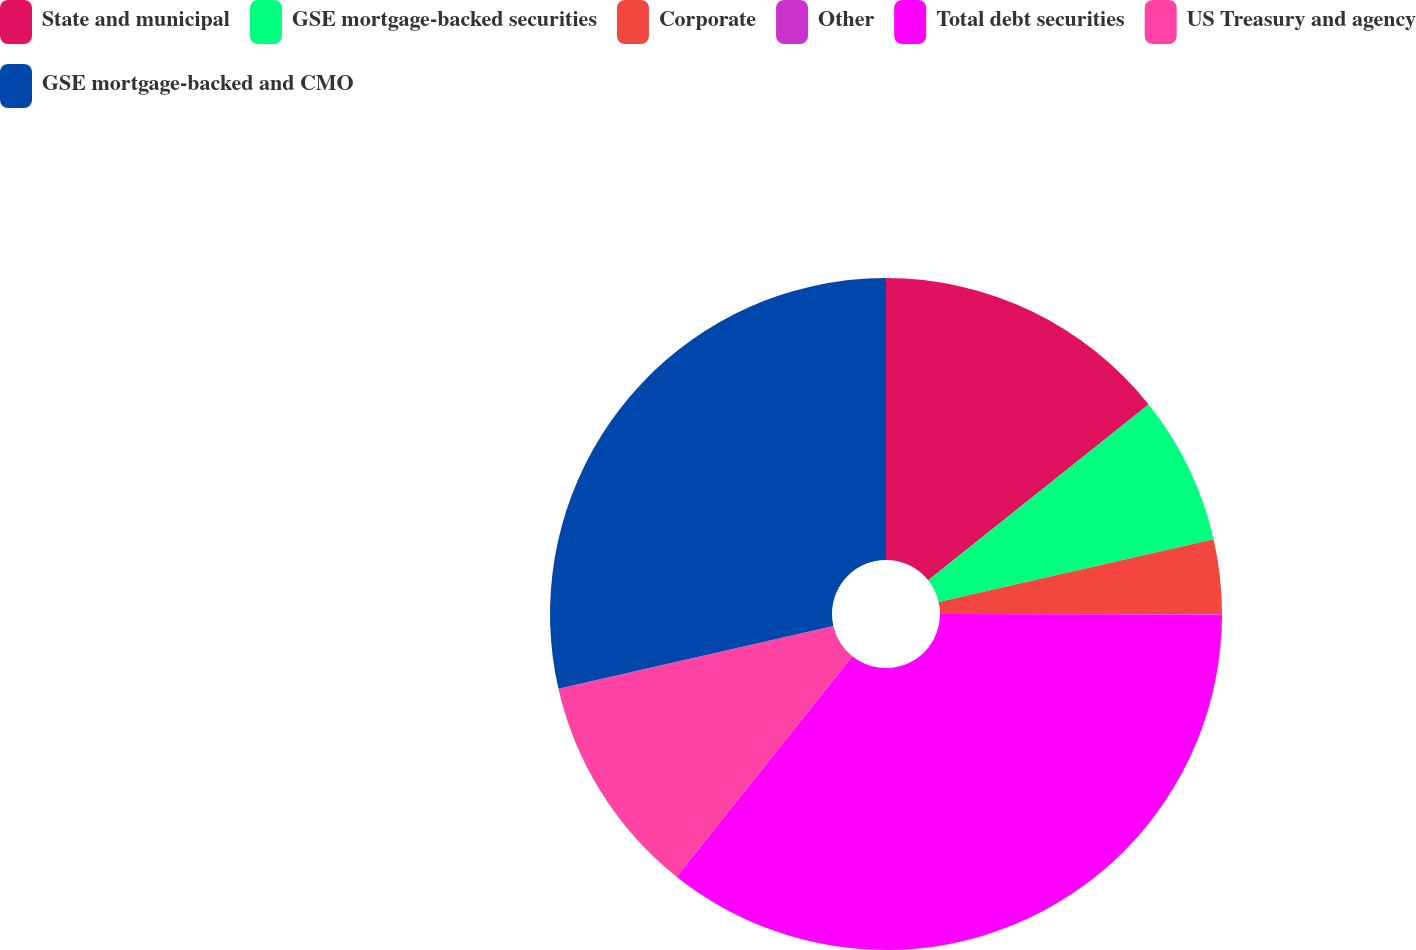Convert chart to OTSL. <chart><loc_0><loc_0><loc_500><loc_500><pie_chart><fcel>State and municipal<fcel>GSE mortgage-backed securities<fcel>Corporate<fcel>Other<fcel>Total debt securities<fcel>US Treasury and agency<fcel>GSE mortgage-backed and CMO<nl><fcel>14.28%<fcel>7.15%<fcel>3.58%<fcel>0.01%<fcel>35.69%<fcel>10.72%<fcel>28.57%<nl></chart> 